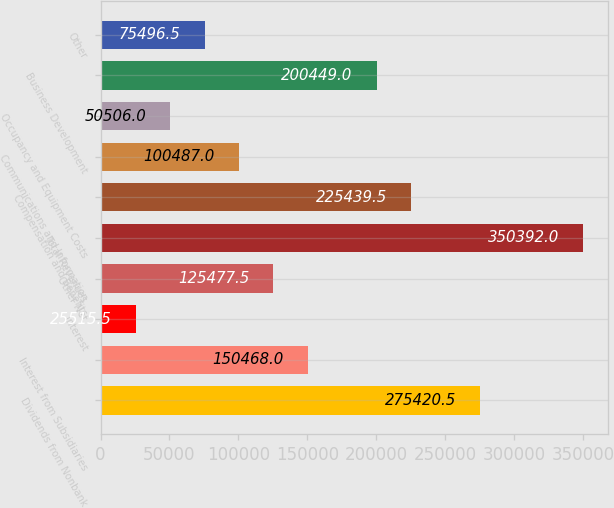<chart> <loc_0><loc_0><loc_500><loc_500><bar_chart><fcel>Dividends from Nonbank<fcel>Interest from Subsidiaries<fcel>Interest<fcel>Other Net<fcel>Total Revenues<fcel>Compensation and Benefits<fcel>Communications and Information<fcel>Occupancy and Equipment Costs<fcel>Business Development<fcel>Other<nl><fcel>275420<fcel>150468<fcel>25515.5<fcel>125478<fcel>350392<fcel>225440<fcel>100487<fcel>50506<fcel>200449<fcel>75496.5<nl></chart> 